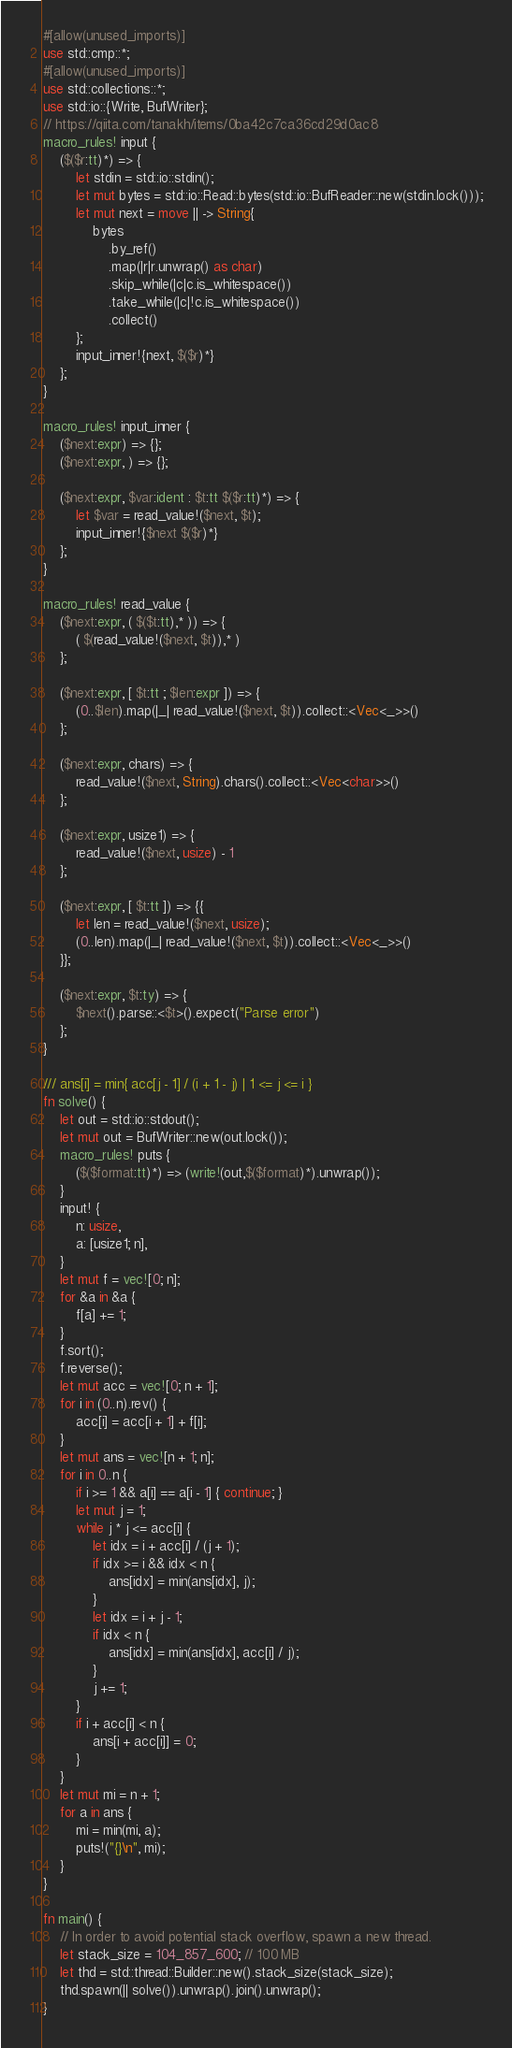<code> <loc_0><loc_0><loc_500><loc_500><_Rust_>#[allow(unused_imports)]
use std::cmp::*;
#[allow(unused_imports)]
use std::collections::*;
use std::io::{Write, BufWriter};
// https://qiita.com/tanakh/items/0ba42c7ca36cd29d0ac8
macro_rules! input {
    ($($r:tt)*) => {
        let stdin = std::io::stdin();
        let mut bytes = std::io::Read::bytes(std::io::BufReader::new(stdin.lock()));
        let mut next = move || -> String{
            bytes
                .by_ref()
                .map(|r|r.unwrap() as char)
                .skip_while(|c|c.is_whitespace())
                .take_while(|c|!c.is_whitespace())
                .collect()
        };
        input_inner!{next, $($r)*}
    };
}

macro_rules! input_inner {
    ($next:expr) => {};
    ($next:expr, ) => {};

    ($next:expr, $var:ident : $t:tt $($r:tt)*) => {
        let $var = read_value!($next, $t);
        input_inner!{$next $($r)*}
    };
}

macro_rules! read_value {
    ($next:expr, ( $($t:tt),* )) => {
        ( $(read_value!($next, $t)),* )
    };

    ($next:expr, [ $t:tt ; $len:expr ]) => {
        (0..$len).map(|_| read_value!($next, $t)).collect::<Vec<_>>()
    };

    ($next:expr, chars) => {
        read_value!($next, String).chars().collect::<Vec<char>>()
    };

    ($next:expr, usize1) => {
        read_value!($next, usize) - 1
    };

    ($next:expr, [ $t:tt ]) => {{
        let len = read_value!($next, usize);
        (0..len).map(|_| read_value!($next, $t)).collect::<Vec<_>>()
    }};

    ($next:expr, $t:ty) => {
        $next().parse::<$t>().expect("Parse error")
    };
}

/// ans[i] = min{ acc[j - 1] / (i + 1 - j) | 1 <= j <= i }
fn solve() {
    let out = std::io::stdout();
    let mut out = BufWriter::new(out.lock());
    macro_rules! puts {
        ($($format:tt)*) => (write!(out,$($format)*).unwrap());
    }
    input! {
        n: usize,
        a: [usize1; n],
    }
    let mut f = vec![0; n];
    for &a in &a {
        f[a] += 1;
    }
    f.sort();
    f.reverse();
    let mut acc = vec![0; n + 1];
    for i in (0..n).rev() {
        acc[i] = acc[i + 1] + f[i];
    }
    let mut ans = vec![n + 1; n];
    for i in 0..n {
        if i >= 1 && a[i] == a[i - 1] { continue; }
        let mut j = 1;
        while j * j <= acc[i] {
            let idx = i + acc[i] / (j + 1);
            if idx >= i && idx < n {
                ans[idx] = min(ans[idx], j);
            }
            let idx = i + j - 1;
            if idx < n {
                ans[idx] = min(ans[idx], acc[i] / j);
            }
            j += 1;
        }
        if i + acc[i] < n {
            ans[i + acc[i]] = 0;
        }
    }
    let mut mi = n + 1;
    for a in ans {
        mi = min(mi, a);
        puts!("{}\n", mi);
    }
}

fn main() {
    // In order to avoid potential stack overflow, spawn a new thread.
    let stack_size = 104_857_600; // 100 MB
    let thd = std::thread::Builder::new().stack_size(stack_size);
    thd.spawn(|| solve()).unwrap().join().unwrap();
}
</code> 